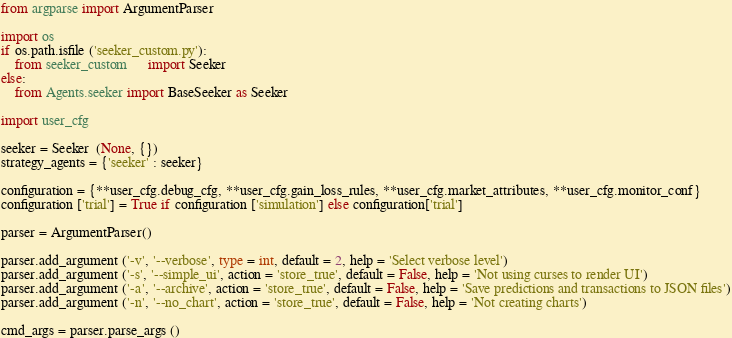Convert code to text. <code><loc_0><loc_0><loc_500><loc_500><_Python_>from argparse import ArgumentParser

import os
if os.path.isfile ('seeker_custom.py'):
	from seeker_custom   	  import Seeker
else:
	from Agents.seeker import BaseSeeker as Seeker

import user_cfg

seeker = Seeker  (None, {})
strategy_agents = {'seeker' : seeker}

configuration = {**user_cfg.debug_cfg, **user_cfg.gain_loss_rules, **user_cfg.market_attributes, **user_cfg.monitor_conf}
configuration ['trial'] = True if configuration ['simulation'] else configuration['trial']

parser = ArgumentParser()

parser.add_argument ('-v', '--verbose', type = int, default = 2, help = 'Select verbose level')
parser.add_argument ('-s', '--simple_ui', action = 'store_true', default = False, help = 'Not using curses to render UI')
parser.add_argument ('-a', '--archive', action = 'store_true', default = False, help = 'Save predictions and transactions to JSON files')
parser.add_argument ('-n', '--no_chart', action = 'store_true', default = False, help = 'Not creating charts')

cmd_args = parser.parse_args ()
</code> 